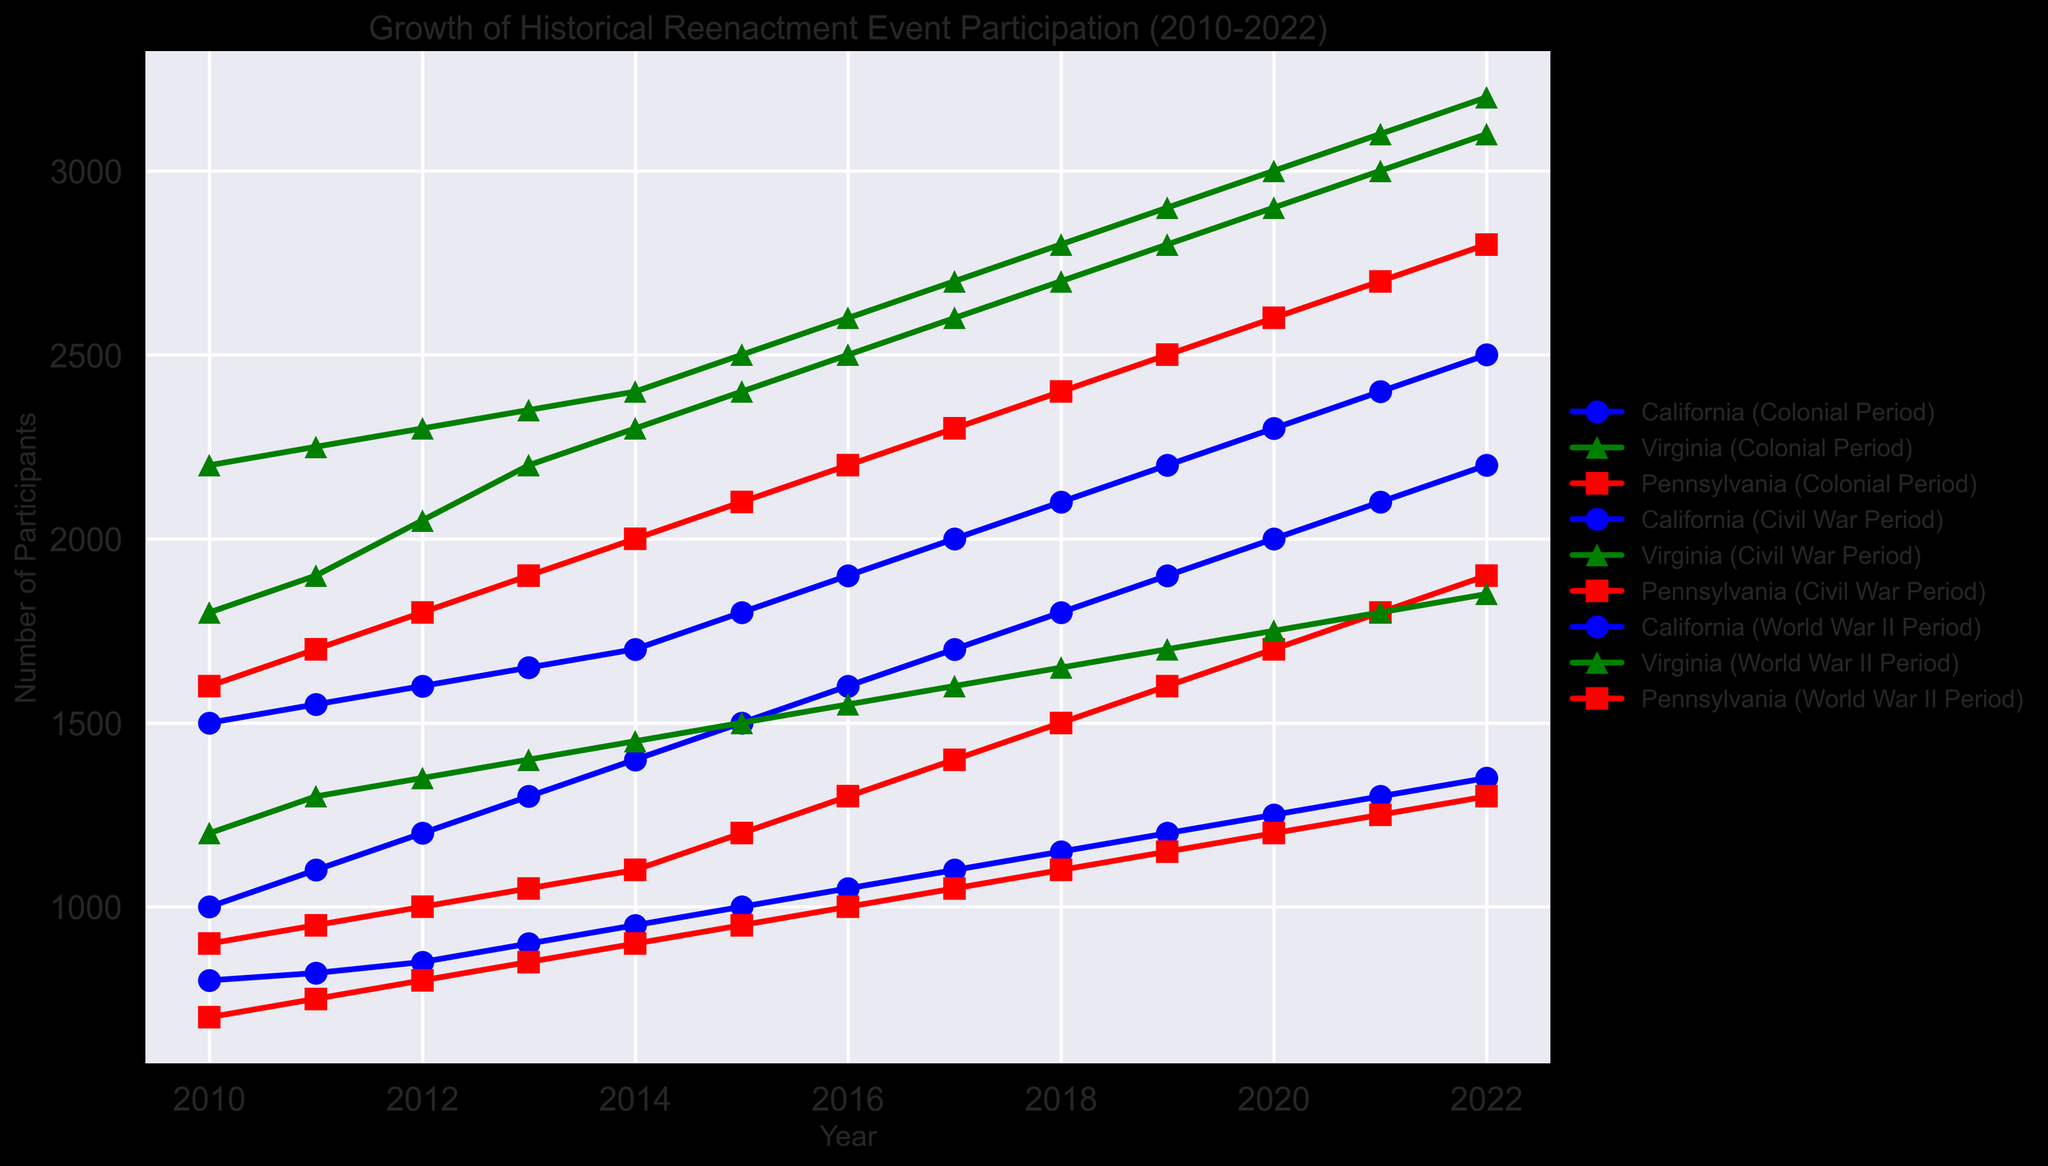Which state had the highest participation for the Colonial Period in 2020? Look at the Colonial Period data points for the year 2020 across different states and identify which state has the highest value. Virginia has the highest participation with 2900.
Answer: Virginia What is the overall trend of Civil War Period participation in California from 2010 to 2022? Observe the line that represents Civil War Period participation for California from 2010 to 2022. The number of participants increased from 1500 in 2010 to 2500 in 2022, showing an overall increasing trend.
Answer: Increasing Compare the participation in the World War II Period in Pennsylvania and Virginia in 2015. Which state had more participants? Look at the World War II Period data points for Pennsylvania and Virginia in 2015. Virginia had 1500 participants, while Pennsylvania had 950 participants. Therefore, Virginia had more participants.
Answer: Virginia What was the average participation for the Colonial Period in Pennsylvania over the years 2010 to 2022? Calculate the average by summing the Colonial Period participation numbers for Pennsylvania from 2010 to 2022 and then dividing by the number of years (13 years). (900+950+1000+1050+1100+1200+1300+1400+1500+1600+1700+1800+1900)/13 = 1307.69.
Answer: 1307.69 Which historical period in Virginia had the most significant increase in participation from 2010 to 2022? Calculate the difference in participation numbers for each historical period from 2010 to 2022 in Virginia. Colonial Period: 3100-1800 = 1300, Civil War Period: 3200-2200 = 1000, World War II Period: 1850-1200 = 650. The Colonial Period had the most significant increase.
Answer: Colonial Period What is the participation difference between California and Pennsylvania for the Civil War Period in 2019? Subtract the Civil War Period participation in Pennsylvania from California for the year 2019. 2200 (California) - 2500 (Pennsylvania) = -300.
Answer: -300 Identify the period with the highest level of participation in Virginia in 2012. Compare the participation levels across all periods in Virginia for the year 2012. The Civil War Period had 2300 participants, more than the other periods.
Answer: Civil War Period Among the three states, which state showed the least variation in Colonial Period participation over the years 2010 to 2022? Consider the range (difference between maximum and minimum values) of Colonial Period participation for each state from 2010 to 2022. Calculate: California (2200-1000=1200), Virginia (3100-1800=1300), Pennsylvania (1900-900=1000). Pennsylvania shows the least variation.
Answer: Pennsylvania 